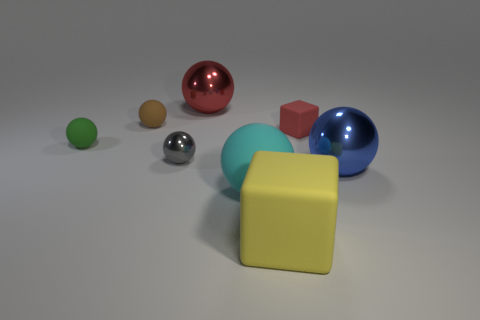Subtract all blue balls. How many balls are left? 5 Subtract all cyan matte spheres. How many spheres are left? 5 Subtract all purple balls. Subtract all green cylinders. How many balls are left? 6 Add 2 blue shiny balls. How many objects exist? 10 Subtract all cubes. How many objects are left? 6 Add 7 blue matte blocks. How many blue matte blocks exist? 7 Subtract 1 gray balls. How many objects are left? 7 Subtract all tiny gray shiny things. Subtract all small green matte balls. How many objects are left? 6 Add 8 red metal spheres. How many red metal spheres are left? 9 